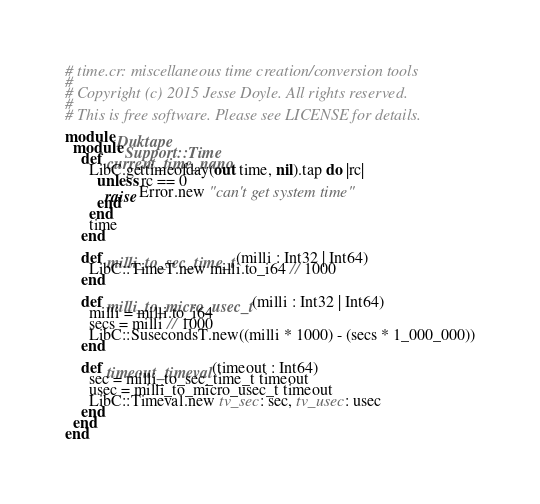Convert code to text. <code><loc_0><loc_0><loc_500><loc_500><_Crystal_># time.cr: miscellaneous time creation/conversion tools
#
# Copyright (c) 2015 Jesse Doyle. All rights reserved.
#
# This is free software. Please see LICENSE for details.

module Duktape
  module Support::Time
    def current_time_nano
      LibC.gettimeofday(out time, nil).tap do |rc|
        unless rc == 0
          raise Error.new "can't get system time"
        end
      end
      time
    end

    def milli_to_sec_time_t(milli : Int32 | Int64)
      LibC::TimeT.new milli.to_i64 // 1000
    end

    def milli_to_micro_usec_t(milli : Int32 | Int64)
      milli = milli.to_i64
      secs = milli // 1000
      LibC::SusecondsT.new((milli * 1000) - (secs * 1_000_000))
    end

    def timeout_timeval(timeout : Int64)
      sec = milli_to_sec_time_t timeout
      usec = milli_to_micro_usec_t timeout
      LibC::Timeval.new tv_sec: sec, tv_usec: usec
    end
  end
end
</code> 